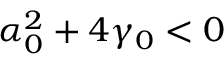Convert formula to latex. <formula><loc_0><loc_0><loc_500><loc_500>\alpha _ { 0 } ^ { 2 } + 4 \gamma _ { 0 } < 0</formula> 